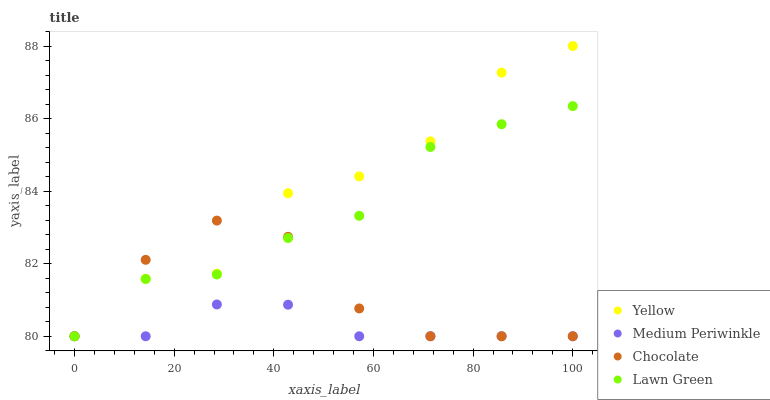Does Medium Periwinkle have the minimum area under the curve?
Answer yes or no. Yes. Does Yellow have the maximum area under the curve?
Answer yes or no. Yes. Does Yellow have the minimum area under the curve?
Answer yes or no. No. Does Medium Periwinkle have the maximum area under the curve?
Answer yes or no. No. Is Medium Periwinkle the smoothest?
Answer yes or no. Yes. Is Yellow the roughest?
Answer yes or no. Yes. Is Yellow the smoothest?
Answer yes or no. No. Is Medium Periwinkle the roughest?
Answer yes or no. No. Does Lawn Green have the lowest value?
Answer yes or no. Yes. Does Yellow have the highest value?
Answer yes or no. Yes. Does Medium Periwinkle have the highest value?
Answer yes or no. No. Does Medium Periwinkle intersect Yellow?
Answer yes or no. Yes. Is Medium Periwinkle less than Yellow?
Answer yes or no. No. Is Medium Periwinkle greater than Yellow?
Answer yes or no. No. 